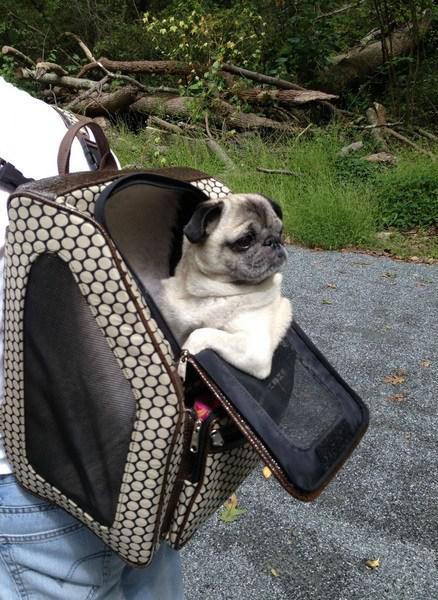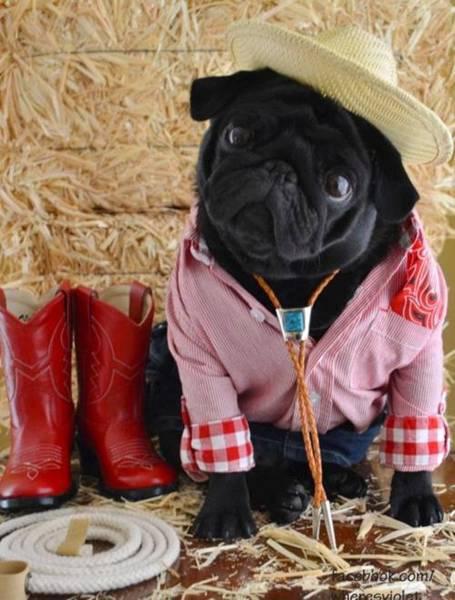The first image is the image on the left, the second image is the image on the right. For the images displayed, is the sentence "a pug is dressed in a costime" factually correct? Answer yes or no. Yes. The first image is the image on the left, the second image is the image on the right. Considering the images on both sides, is "One of the dogs is dressed in a costume and the other dog's head is hanging out of a backpack." valid? Answer yes or no. Yes. 